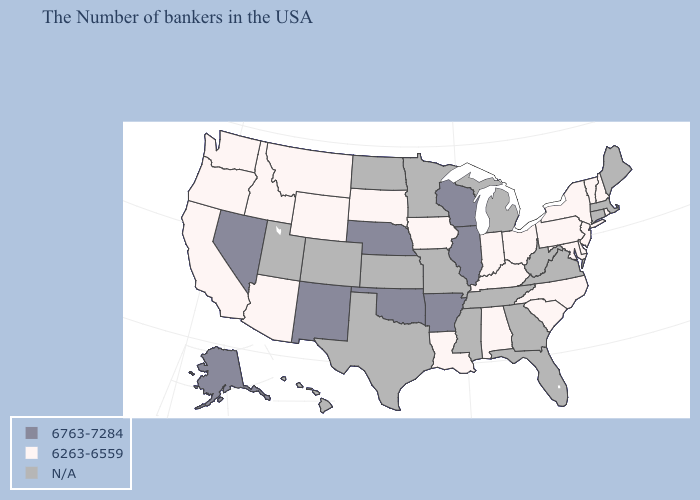Name the states that have a value in the range 6763-7284?
Keep it brief. Wisconsin, Illinois, Arkansas, Nebraska, Oklahoma, New Mexico, Nevada, Alaska. How many symbols are there in the legend?
Keep it brief. 3. Name the states that have a value in the range N/A?
Concise answer only. Maine, Massachusetts, Connecticut, Virginia, West Virginia, Florida, Georgia, Michigan, Tennessee, Mississippi, Missouri, Minnesota, Kansas, Texas, North Dakota, Colorado, Utah, Hawaii. Name the states that have a value in the range 6263-6559?
Answer briefly. Rhode Island, New Hampshire, Vermont, New York, New Jersey, Delaware, Maryland, Pennsylvania, North Carolina, South Carolina, Ohio, Kentucky, Indiana, Alabama, Louisiana, Iowa, South Dakota, Wyoming, Montana, Arizona, Idaho, California, Washington, Oregon. What is the value of Arizona?
Quick response, please. 6263-6559. What is the value of Texas?
Write a very short answer. N/A. Does Arkansas have the highest value in the South?
Answer briefly. Yes. What is the lowest value in the USA?
Give a very brief answer. 6263-6559. Name the states that have a value in the range 6763-7284?
Concise answer only. Wisconsin, Illinois, Arkansas, Nebraska, Oklahoma, New Mexico, Nevada, Alaska. Name the states that have a value in the range N/A?
Give a very brief answer. Maine, Massachusetts, Connecticut, Virginia, West Virginia, Florida, Georgia, Michigan, Tennessee, Mississippi, Missouri, Minnesota, Kansas, Texas, North Dakota, Colorado, Utah, Hawaii. What is the value of South Dakota?
Answer briefly. 6263-6559. What is the value of New Mexico?
Concise answer only. 6763-7284. Among the states that border Kentucky , which have the highest value?
Short answer required. Illinois. 